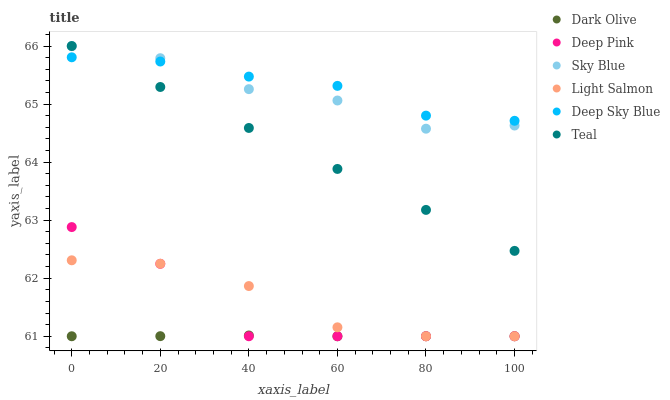Does Dark Olive have the minimum area under the curve?
Answer yes or no. Yes. Does Deep Sky Blue have the maximum area under the curve?
Answer yes or no. Yes. Does Deep Pink have the minimum area under the curve?
Answer yes or no. No. Does Deep Pink have the maximum area under the curve?
Answer yes or no. No. Is Teal the smoothest?
Answer yes or no. Yes. Is Deep Pink the roughest?
Answer yes or no. Yes. Is Deep Sky Blue the smoothest?
Answer yes or no. No. Is Deep Sky Blue the roughest?
Answer yes or no. No. Does Light Salmon have the lowest value?
Answer yes or no. Yes. Does Deep Sky Blue have the lowest value?
Answer yes or no. No. Does Teal have the highest value?
Answer yes or no. Yes. Does Deep Pink have the highest value?
Answer yes or no. No. Is Dark Olive less than Sky Blue?
Answer yes or no. Yes. Is Teal greater than Dark Olive?
Answer yes or no. Yes. Does Light Salmon intersect Dark Olive?
Answer yes or no. Yes. Is Light Salmon less than Dark Olive?
Answer yes or no. No. Is Light Salmon greater than Dark Olive?
Answer yes or no. No. Does Dark Olive intersect Sky Blue?
Answer yes or no. No. 